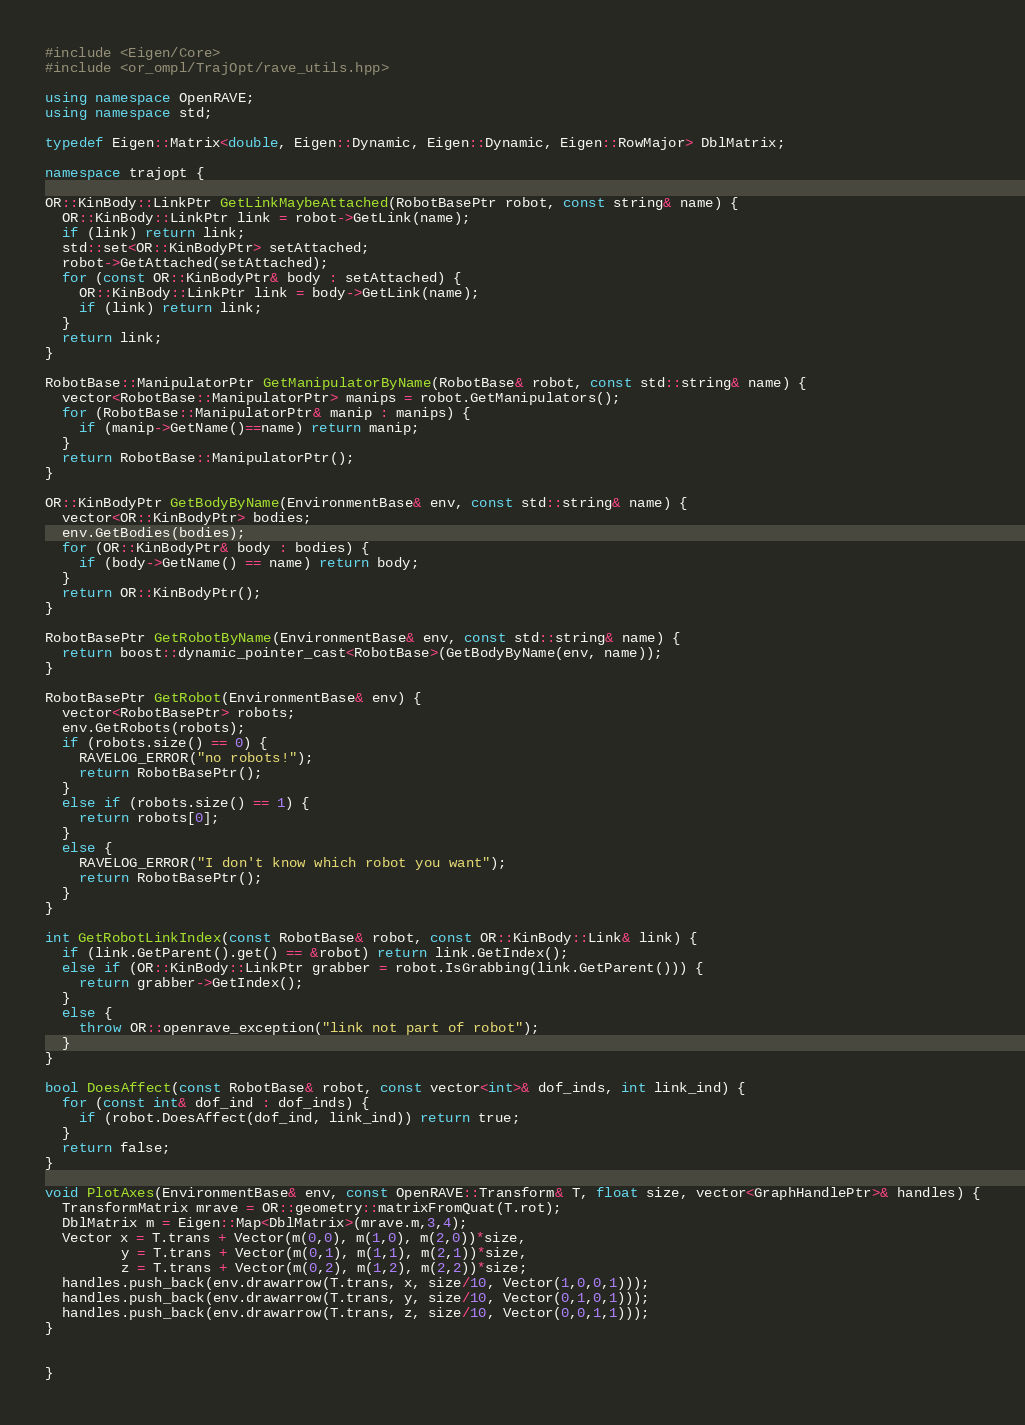Convert code to text. <code><loc_0><loc_0><loc_500><loc_500><_C++_>#include <Eigen/Core>
#include <or_ompl/TrajOpt/rave_utils.hpp>

using namespace OpenRAVE;
using namespace std;

typedef Eigen::Matrix<double, Eigen::Dynamic, Eigen::Dynamic, Eigen::RowMajor> DblMatrix;

namespace trajopt {

OR::KinBody::LinkPtr GetLinkMaybeAttached(RobotBasePtr robot, const string& name) {
  OR::KinBody::LinkPtr link = robot->GetLink(name);
  if (link) return link;
  std::set<OR::KinBodyPtr> setAttached;
  robot->GetAttached(setAttached);
  for (const OR::KinBodyPtr& body : setAttached) {
    OR::KinBody::LinkPtr link = body->GetLink(name);
    if (link) return link;
  }
  return link;
}

RobotBase::ManipulatorPtr GetManipulatorByName(RobotBase& robot, const std::string& name) {
  vector<RobotBase::ManipulatorPtr> manips = robot.GetManipulators();
  for (RobotBase::ManipulatorPtr& manip : manips) {
    if (manip->GetName()==name) return manip;
  }
  return RobotBase::ManipulatorPtr();
}

OR::KinBodyPtr GetBodyByName(EnvironmentBase& env, const std::string& name) {
  vector<OR::KinBodyPtr> bodies;
  env.GetBodies(bodies);
  for (OR::KinBodyPtr& body : bodies) {
    if (body->GetName() == name) return body;
  }
  return OR::KinBodyPtr();
}

RobotBasePtr GetRobotByName(EnvironmentBase& env, const std::string& name) {
  return boost::dynamic_pointer_cast<RobotBase>(GetBodyByName(env, name));
}

RobotBasePtr GetRobot(EnvironmentBase& env) {
  vector<RobotBasePtr> robots;
  env.GetRobots(robots);
  if (robots.size() == 0) {
    RAVELOG_ERROR("no robots!");
    return RobotBasePtr();
  }
  else if (robots.size() == 1) {
    return robots[0];
  }
  else {
    RAVELOG_ERROR("I don't know which robot you want");
    return RobotBasePtr();
  }
}

int GetRobotLinkIndex(const RobotBase& robot, const OR::KinBody::Link& link) {
  if (link.GetParent().get() == &robot) return link.GetIndex();
  else if (OR::KinBody::LinkPtr grabber = robot.IsGrabbing(link.GetParent())) {
    return grabber->GetIndex();
  }
  else {
    throw OR::openrave_exception("link not part of robot");
  }
}

bool DoesAffect(const RobotBase& robot, const vector<int>& dof_inds, int link_ind) {
  for (const int& dof_ind : dof_inds) {
    if (robot.DoesAffect(dof_ind, link_ind)) return true;
  }
  return false;
}

void PlotAxes(EnvironmentBase& env, const OpenRAVE::Transform& T, float size, vector<GraphHandlePtr>& handles) {
  TransformMatrix mrave = OR::geometry::matrixFromQuat(T.rot);
  DblMatrix m = Eigen::Map<DblMatrix>(mrave.m,3,4);
  Vector x = T.trans + Vector(m(0,0), m(1,0), m(2,0))*size,
         y = T.trans + Vector(m(0,1), m(1,1), m(2,1))*size,
         z = T.trans + Vector(m(0,2), m(1,2), m(2,2))*size;
  handles.push_back(env.drawarrow(T.trans, x, size/10, Vector(1,0,0,1)));
  handles.push_back(env.drawarrow(T.trans, y, size/10, Vector(0,1,0,1)));
  handles.push_back(env.drawarrow(T.trans, z, size/10, Vector(0,0,1,1)));
}


}
</code> 